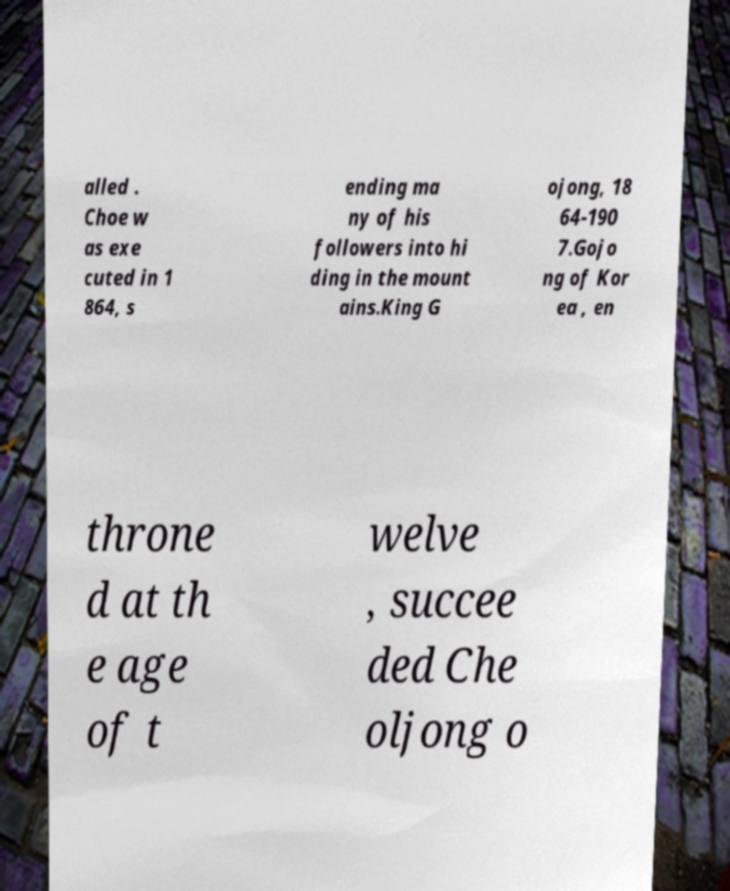Please identify and transcribe the text found in this image. alled . Choe w as exe cuted in 1 864, s ending ma ny of his followers into hi ding in the mount ains.King G ojong, 18 64-190 7.Gojo ng of Kor ea , en throne d at th e age of t welve , succee ded Che oljong o 